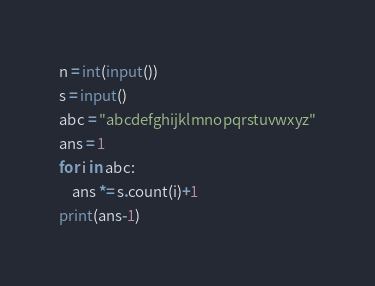Convert code to text. <code><loc_0><loc_0><loc_500><loc_500><_Python_>n = int(input())
s = input()
abc = "abcdefghijklmnopqrstuvwxyz"
ans = 1
for i in abc:
    ans *= s.count(i)+1
print(ans-1)</code> 